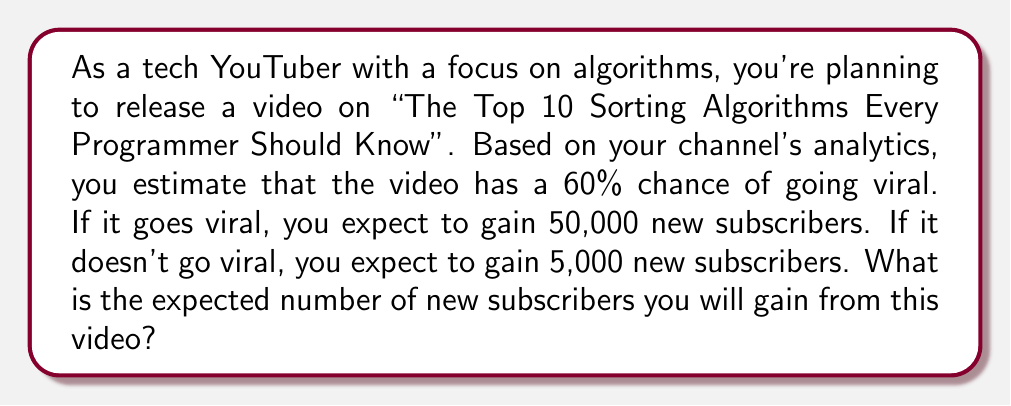Could you help me with this problem? Let's approach this step-by-step using the concept of expected value:

1) First, let's define our events and their probabilities:
   - Event A: Video goes viral (probability = 0.60)
   - Event B: Video doesn't go viral (probability = 1 - 0.60 = 0.40)

2) Now, let's define the number of subscribers gained for each event:
   - If Event A occurs: 50,000 new subscribers
   - If Event B occurs: 5,000 new subscribers

3) The formula for expected value is:
   $$E(X) = \sum_{i=1}^{n} p_i x_i$$
   where $p_i$ is the probability of event $i$ occurring, and $x_i$ is the value if event $i$ occurs.

4) Applying this formula to our problem:
   $$E(\text{subscribers}) = (0.60 \times 50,000) + (0.40 \times 5,000)$$

5) Let's calculate:
   $$E(\text{subscribers}) = 30,000 + 2,000 = 32,000$$

Therefore, the expected number of new subscribers from this video is 32,000.
Answer: 32,000 subscribers 